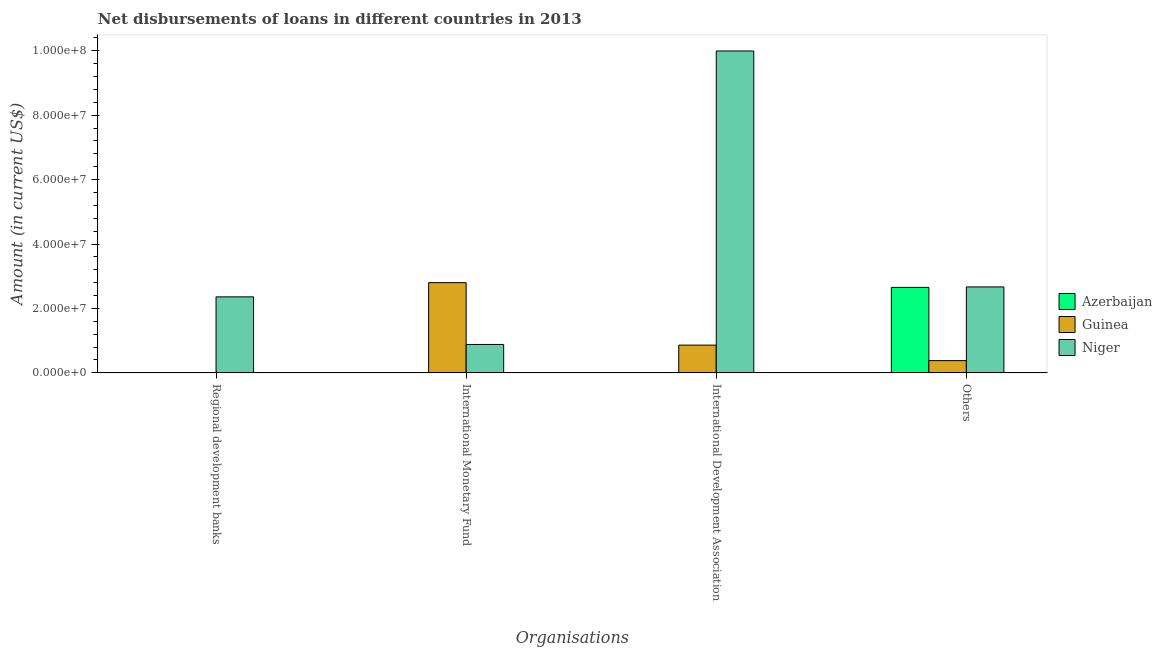Are the number of bars per tick equal to the number of legend labels?
Your response must be concise. No. How many bars are there on the 3rd tick from the right?
Your answer should be compact. 2. What is the label of the 1st group of bars from the left?
Provide a succinct answer. Regional development banks. What is the amount of loan disimbursed by international development association in Guinea?
Provide a succinct answer. 8.62e+06. Across all countries, what is the maximum amount of loan disimbursed by international development association?
Provide a short and direct response. 9.99e+07. Across all countries, what is the minimum amount of loan disimbursed by regional development banks?
Provide a succinct answer. 0. In which country was the amount of loan disimbursed by international development association maximum?
Give a very brief answer. Niger. What is the total amount of loan disimbursed by international development association in the graph?
Keep it short and to the point. 1.09e+08. What is the difference between the amount of loan disimbursed by international development association in Niger and that in Guinea?
Your answer should be very brief. 9.13e+07. What is the average amount of loan disimbursed by international monetary fund per country?
Make the answer very short. 1.23e+07. What is the difference between the amount of loan disimbursed by international monetary fund and amount of loan disimbursed by regional development banks in Niger?
Your answer should be very brief. -1.48e+07. What is the difference between the highest and the second highest amount of loan disimbursed by other organisations?
Offer a terse response. 1.48e+05. What is the difference between the highest and the lowest amount of loan disimbursed by other organisations?
Your response must be concise. 2.29e+07. In how many countries, is the amount of loan disimbursed by regional development banks greater than the average amount of loan disimbursed by regional development banks taken over all countries?
Provide a succinct answer. 1. Is the sum of the amount of loan disimbursed by other organisations in Guinea and Niger greater than the maximum amount of loan disimbursed by regional development banks across all countries?
Your answer should be compact. Yes. Is it the case that in every country, the sum of the amount of loan disimbursed by regional development banks and amount of loan disimbursed by international monetary fund is greater than the amount of loan disimbursed by international development association?
Your answer should be very brief. No. How many bars are there?
Provide a short and direct response. 8. Are the values on the major ticks of Y-axis written in scientific E-notation?
Give a very brief answer. Yes. Does the graph contain any zero values?
Give a very brief answer. Yes. How many legend labels are there?
Your answer should be compact. 3. How are the legend labels stacked?
Keep it short and to the point. Vertical. What is the title of the graph?
Your response must be concise. Net disbursements of loans in different countries in 2013. Does "High income" appear as one of the legend labels in the graph?
Your response must be concise. No. What is the label or title of the X-axis?
Offer a very short reply. Organisations. What is the Amount (in current US$) of Azerbaijan in Regional development banks?
Give a very brief answer. 0. What is the Amount (in current US$) in Niger in Regional development banks?
Your answer should be very brief. 2.36e+07. What is the Amount (in current US$) in Azerbaijan in International Monetary Fund?
Make the answer very short. 0. What is the Amount (in current US$) in Guinea in International Monetary Fund?
Ensure brevity in your answer.  2.80e+07. What is the Amount (in current US$) in Niger in International Monetary Fund?
Keep it short and to the point. 8.82e+06. What is the Amount (in current US$) in Guinea in International Development Association?
Give a very brief answer. 8.62e+06. What is the Amount (in current US$) of Niger in International Development Association?
Offer a terse response. 9.99e+07. What is the Amount (in current US$) in Azerbaijan in Others?
Your response must be concise. 2.65e+07. What is the Amount (in current US$) in Guinea in Others?
Offer a terse response. 3.80e+06. What is the Amount (in current US$) in Niger in Others?
Make the answer very short. 2.67e+07. Across all Organisations, what is the maximum Amount (in current US$) of Azerbaijan?
Make the answer very short. 2.65e+07. Across all Organisations, what is the maximum Amount (in current US$) of Guinea?
Your answer should be compact. 2.80e+07. Across all Organisations, what is the maximum Amount (in current US$) in Niger?
Make the answer very short. 9.99e+07. Across all Organisations, what is the minimum Amount (in current US$) in Azerbaijan?
Offer a terse response. 0. Across all Organisations, what is the minimum Amount (in current US$) in Niger?
Provide a short and direct response. 8.82e+06. What is the total Amount (in current US$) of Azerbaijan in the graph?
Offer a terse response. 2.65e+07. What is the total Amount (in current US$) in Guinea in the graph?
Give a very brief answer. 4.04e+07. What is the total Amount (in current US$) of Niger in the graph?
Make the answer very short. 1.59e+08. What is the difference between the Amount (in current US$) in Niger in Regional development banks and that in International Monetary Fund?
Ensure brevity in your answer.  1.48e+07. What is the difference between the Amount (in current US$) in Niger in Regional development banks and that in International Development Association?
Keep it short and to the point. -7.63e+07. What is the difference between the Amount (in current US$) of Niger in Regional development banks and that in Others?
Your response must be concise. -3.09e+06. What is the difference between the Amount (in current US$) of Guinea in International Monetary Fund and that in International Development Association?
Your response must be concise. 1.94e+07. What is the difference between the Amount (in current US$) in Niger in International Monetary Fund and that in International Development Association?
Your answer should be very brief. -9.11e+07. What is the difference between the Amount (in current US$) of Guinea in International Monetary Fund and that in Others?
Your answer should be compact. 2.42e+07. What is the difference between the Amount (in current US$) of Niger in International Monetary Fund and that in Others?
Offer a terse response. -1.79e+07. What is the difference between the Amount (in current US$) in Guinea in International Development Association and that in Others?
Your answer should be compact. 4.82e+06. What is the difference between the Amount (in current US$) of Niger in International Development Association and that in Others?
Your answer should be compact. 7.32e+07. What is the difference between the Amount (in current US$) in Guinea in International Monetary Fund and the Amount (in current US$) in Niger in International Development Association?
Ensure brevity in your answer.  -7.19e+07. What is the difference between the Amount (in current US$) in Guinea in International Monetary Fund and the Amount (in current US$) in Niger in Others?
Your answer should be very brief. 1.33e+06. What is the difference between the Amount (in current US$) of Guinea in International Development Association and the Amount (in current US$) of Niger in Others?
Offer a terse response. -1.81e+07. What is the average Amount (in current US$) in Azerbaijan per Organisations?
Provide a short and direct response. 6.63e+06. What is the average Amount (in current US$) of Guinea per Organisations?
Your answer should be very brief. 1.01e+07. What is the average Amount (in current US$) in Niger per Organisations?
Ensure brevity in your answer.  3.98e+07. What is the difference between the Amount (in current US$) of Guinea and Amount (in current US$) of Niger in International Monetary Fund?
Offer a very short reply. 1.92e+07. What is the difference between the Amount (in current US$) of Guinea and Amount (in current US$) of Niger in International Development Association?
Your response must be concise. -9.13e+07. What is the difference between the Amount (in current US$) in Azerbaijan and Amount (in current US$) in Guinea in Others?
Your answer should be compact. 2.27e+07. What is the difference between the Amount (in current US$) of Azerbaijan and Amount (in current US$) of Niger in Others?
Make the answer very short. -1.48e+05. What is the difference between the Amount (in current US$) of Guinea and Amount (in current US$) of Niger in Others?
Make the answer very short. -2.29e+07. What is the ratio of the Amount (in current US$) of Niger in Regional development banks to that in International Monetary Fund?
Provide a succinct answer. 2.68. What is the ratio of the Amount (in current US$) of Niger in Regional development banks to that in International Development Association?
Your answer should be very brief. 0.24. What is the ratio of the Amount (in current US$) of Niger in Regional development banks to that in Others?
Provide a short and direct response. 0.88. What is the ratio of the Amount (in current US$) of Guinea in International Monetary Fund to that in International Development Association?
Keep it short and to the point. 3.25. What is the ratio of the Amount (in current US$) in Niger in International Monetary Fund to that in International Development Association?
Make the answer very short. 0.09. What is the ratio of the Amount (in current US$) of Guinea in International Monetary Fund to that in Others?
Your answer should be very brief. 7.37. What is the ratio of the Amount (in current US$) of Niger in International Monetary Fund to that in Others?
Your answer should be compact. 0.33. What is the ratio of the Amount (in current US$) in Guinea in International Development Association to that in Others?
Your answer should be compact. 2.27. What is the ratio of the Amount (in current US$) of Niger in International Development Association to that in Others?
Provide a succinct answer. 3.75. What is the difference between the highest and the second highest Amount (in current US$) of Guinea?
Offer a very short reply. 1.94e+07. What is the difference between the highest and the second highest Amount (in current US$) in Niger?
Offer a very short reply. 7.32e+07. What is the difference between the highest and the lowest Amount (in current US$) in Azerbaijan?
Ensure brevity in your answer.  2.65e+07. What is the difference between the highest and the lowest Amount (in current US$) of Guinea?
Provide a succinct answer. 2.80e+07. What is the difference between the highest and the lowest Amount (in current US$) in Niger?
Offer a very short reply. 9.11e+07. 